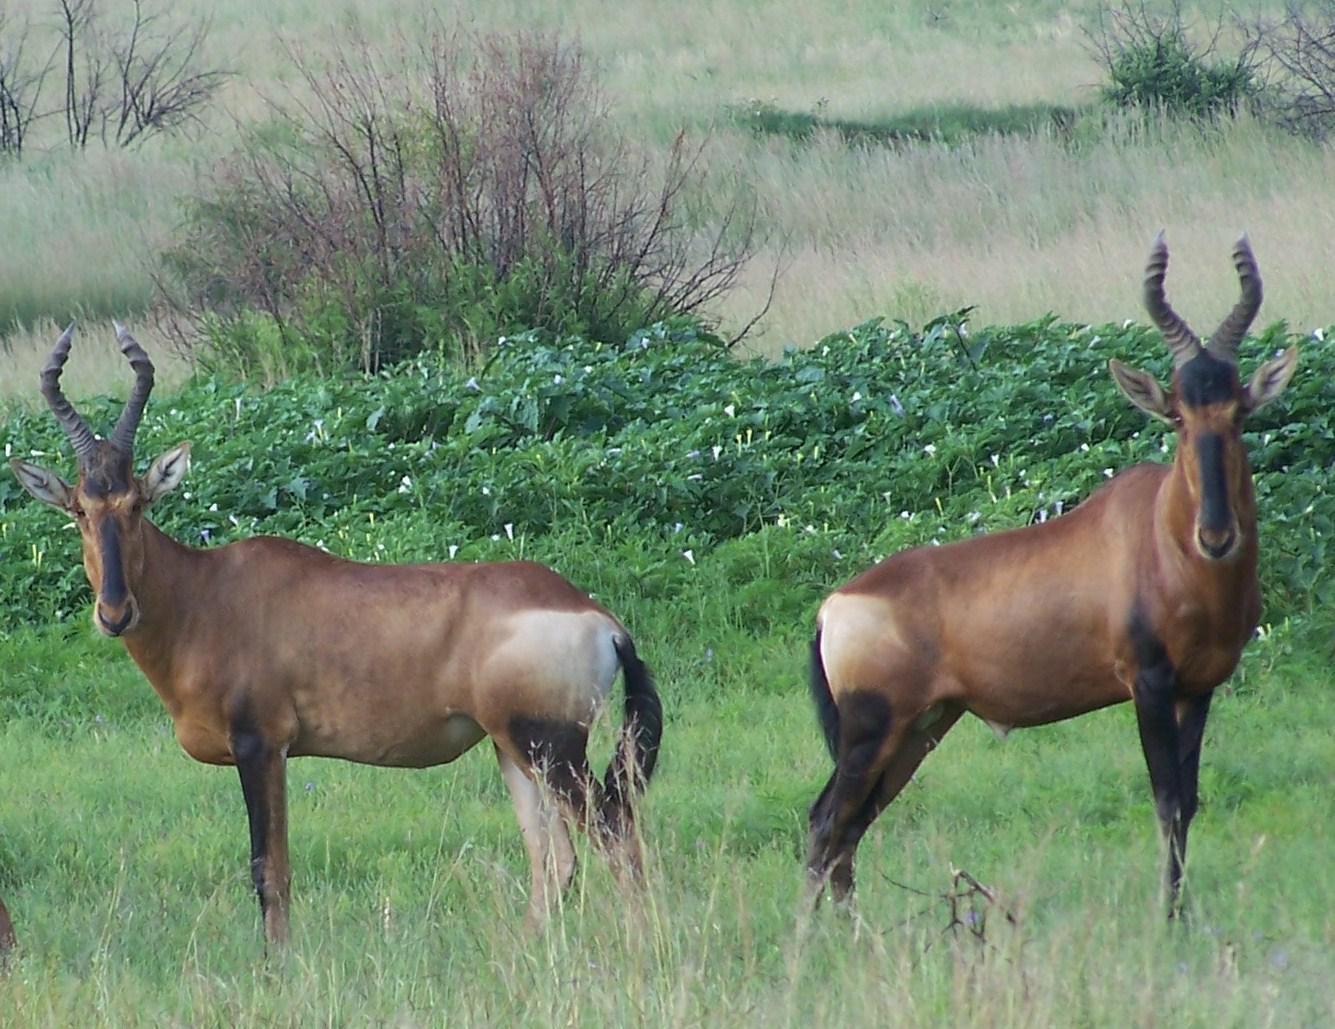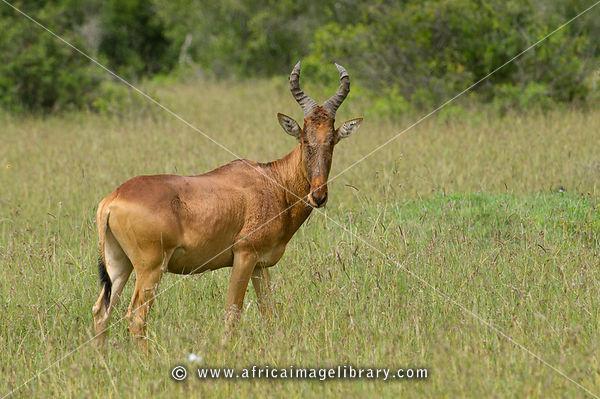The first image is the image on the left, the second image is the image on the right. Evaluate the accuracy of this statement regarding the images: "Lefthand image contains two horned animals standing in a field.". Is it true? Answer yes or no. Yes. The first image is the image on the left, the second image is the image on the right. For the images shown, is this caption "One of the images shows exactly two antelopes that are standing." true? Answer yes or no. Yes. 